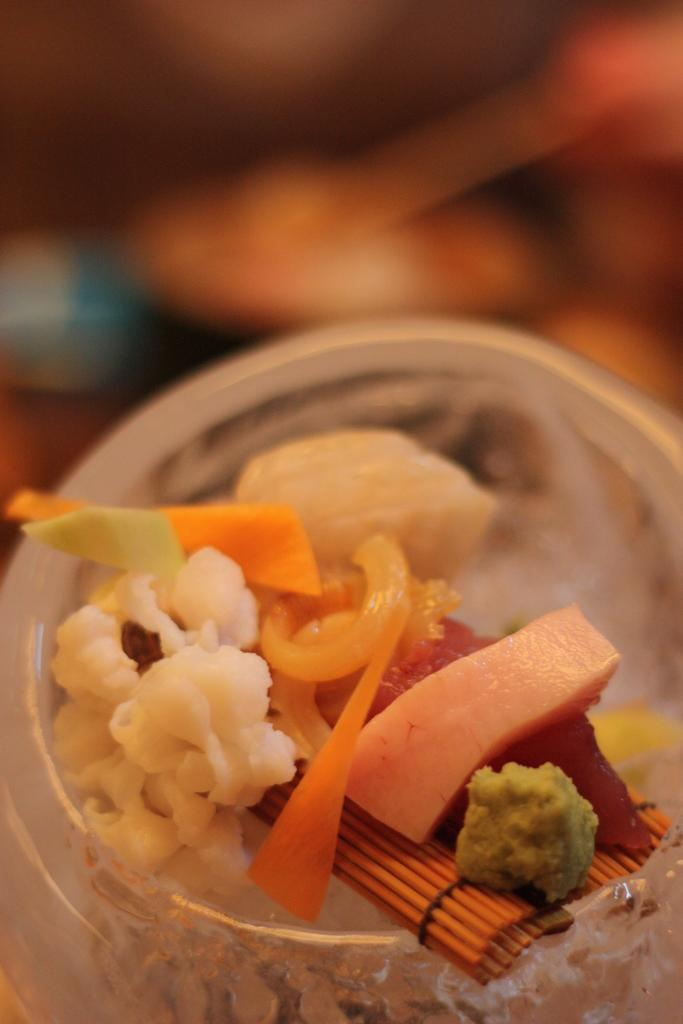What is in the bowl that is visible in the image? There is a bowl with food items in the image. Can you describe the background of the image? The background of the image is blurred. How many men are holding letters in the image? There are no men or letters present in the image. 